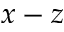Convert formula to latex. <formula><loc_0><loc_0><loc_500><loc_500>x - z</formula> 